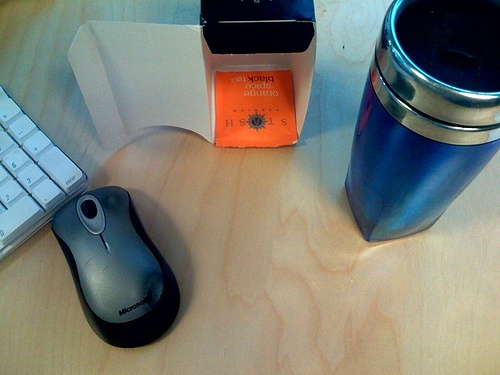Describe the objects in this image and their specific colors. I can see cup in darkgreen, black, navy, gray, and blue tones, mouse in darkgreen, black, blue, teal, and darkblue tones, and keyboard in darkgreen, lightblue, and gray tones in this image. 